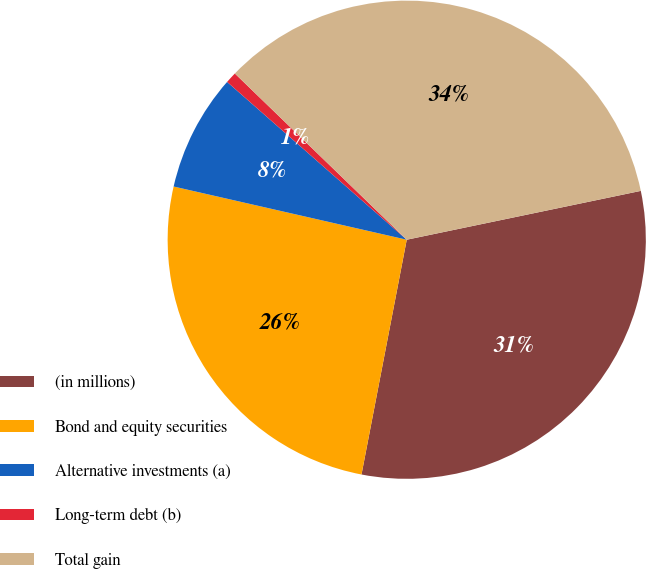Convert chart to OTSL. <chart><loc_0><loc_0><loc_500><loc_500><pie_chart><fcel>(in millions)<fcel>Bond and equity securities<fcel>Alternative investments (a)<fcel>Long-term debt (b)<fcel>Total gain<nl><fcel>31.3%<fcel>25.54%<fcel>7.9%<fcel>0.76%<fcel>34.49%<nl></chart> 